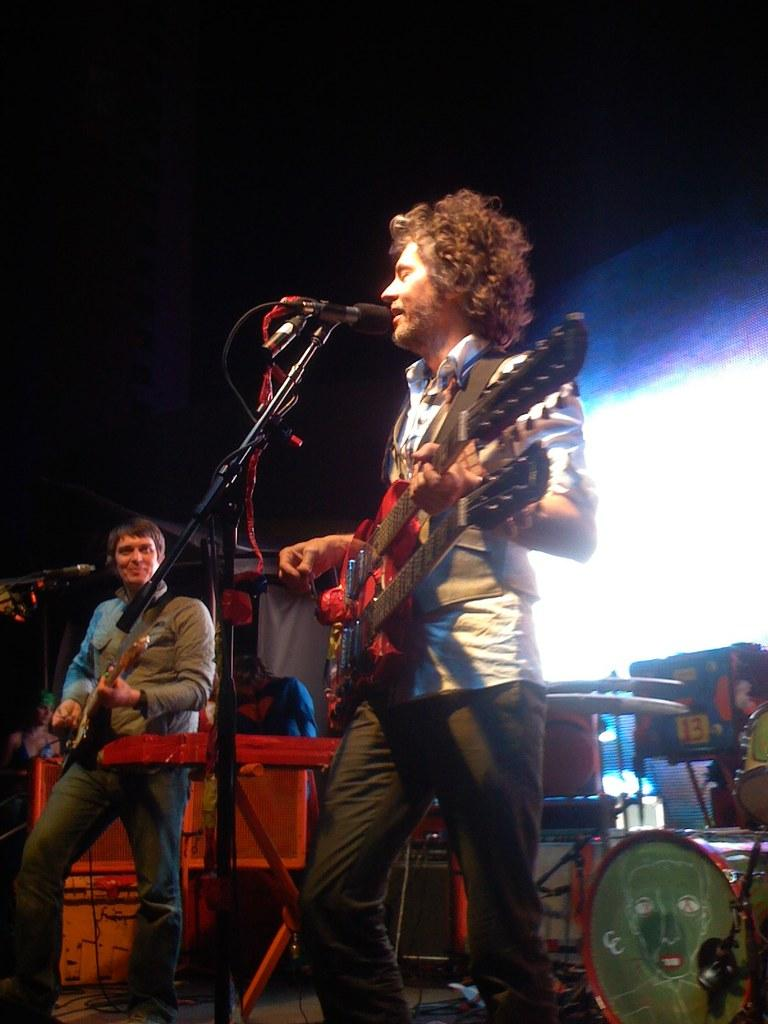How many people are in the image? There are two persons in the image. What are the persons doing in the image? The persons are standing in front of a microphone and playing a guitar. What can be seen in the background of the image? There is a screen in the background of the image. What other objects are present in the image besides the persons and the screen? There are musical instruments in the image. What type of ground can be seen beneath the persons in the image? There is no ground visible in the image; it appears to be an indoor setting. What room are the persons in, and what color is the wallpaper? The image does not provide enough information to determine the specific room or the color of the wallpaper. 